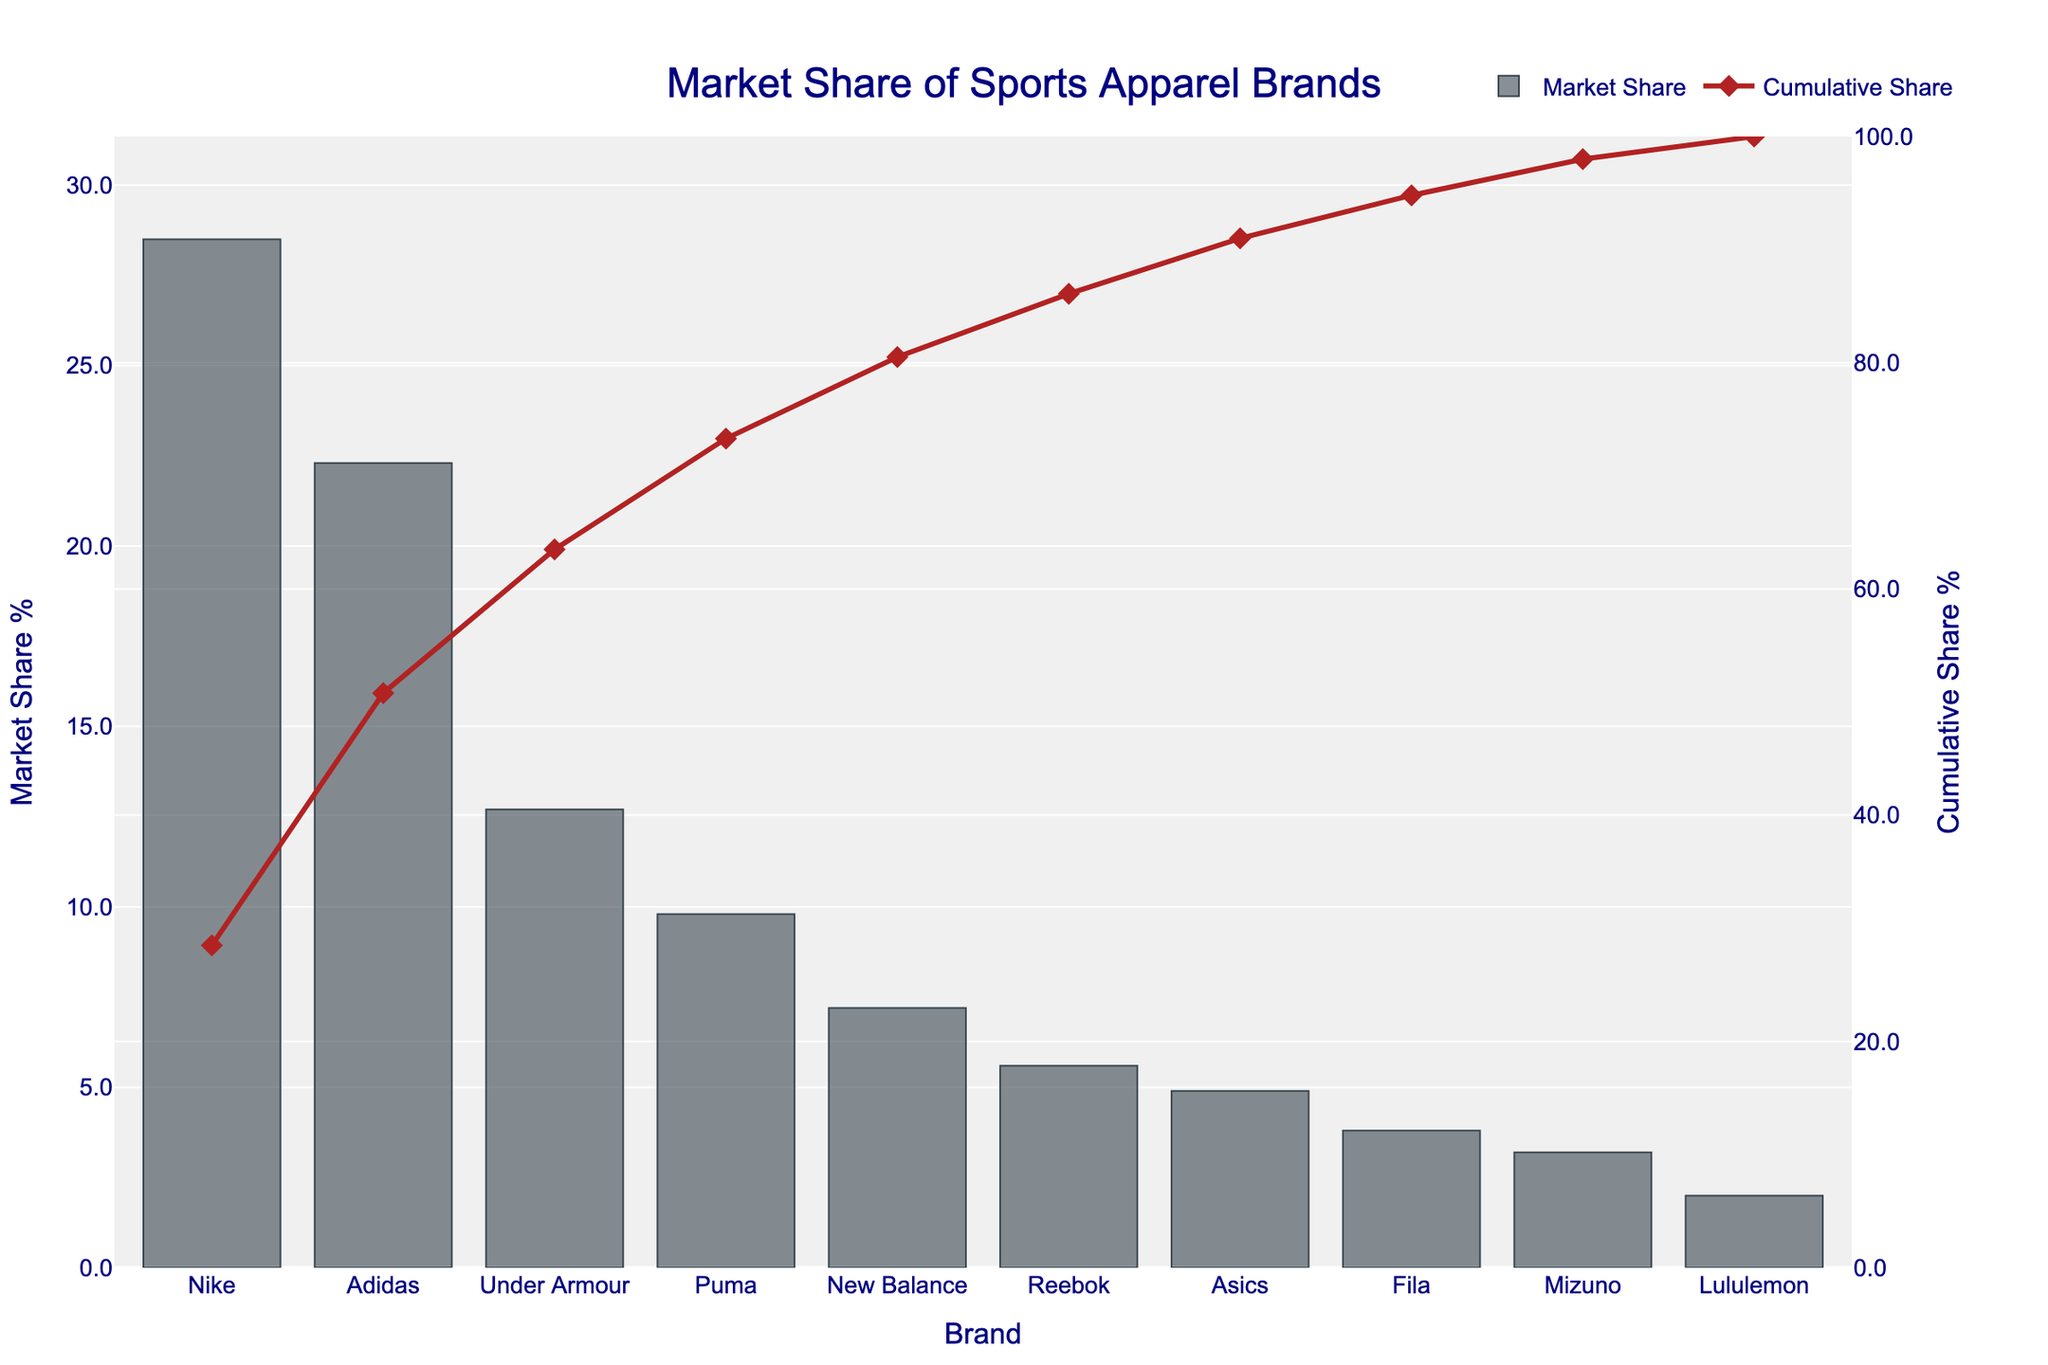What is the brand with the highest market share percentage? The bar representing Nike is the tallest, indicating the highest market share percentage. Hence, Nike has the highest market share percentage.
Answer: Nike How much more market share does Adidas have compared to Under Armour? The market share percentage for Adidas is 22.3%, and for Under Armour, it is 12.7%. The difference is calculated as 22.3% - 12.7% = 9.6%.
Answer: 9.6% Which brands have a market share percentage higher than 10%? By visually inspecting the height of the bars, we see that Nike, Adidas, and Under Armour have bars higher than the 10% mark on the y-axis.
Answer: Nike, Adidas, Under Armour What is the cumulative market share percentage after including the top three brands? Cumulative share can be observed by following the red line after the third brand (Under Armour). The cumulative share after the third brand is closest to the given value at that point on the red line.
Answer: 63.5% Which brand has the smallest market share, and by how much is it smaller than Reebok? Lululemon has the smallest market share percentage at 2.0%, while Reebok has 5.6%. The difference is 5.6% - 2.0% = 3.6%.
Answer: Lululemon, 3.6% What is the combined market share percentage of New Balance, Reebok, and Asics? The market share percentages are 7.2% for New Balance, 5.6% for Reebok, and 4.9% for Asics. The sum is 7.2% + 5.6% + 4.9% = 17.7%.
Answer: 17.7% Does Fila have a higher market share than Mizuno, and by how much? Fila's market share percentage is 3.8%, whereas Mizuno's is 3.2%. The difference is 3.8% - 3.2% = 0.6%.
Answer: Yes, by 0.6% Among the brands listed, what is the median market share percentage? To find the median, we list percentages in ascending order: 2.0, 3.2, 3.8, 4.9, 5.6, 7.2, 9.8, 12.7, 22.3, 28.5. The median is the average of the 5th and 6th values: (5.6 + 7.2) / 2 = 6.4.
Answer: 6.4 What is the ratio of the market share percentage of Nike to that of Puma? Nike's market share percentage is 28.5%, and Puma's is 9.8%. The ratio is 28.5 / 9.8 ≈ 2.91.
Answer: 2.91 